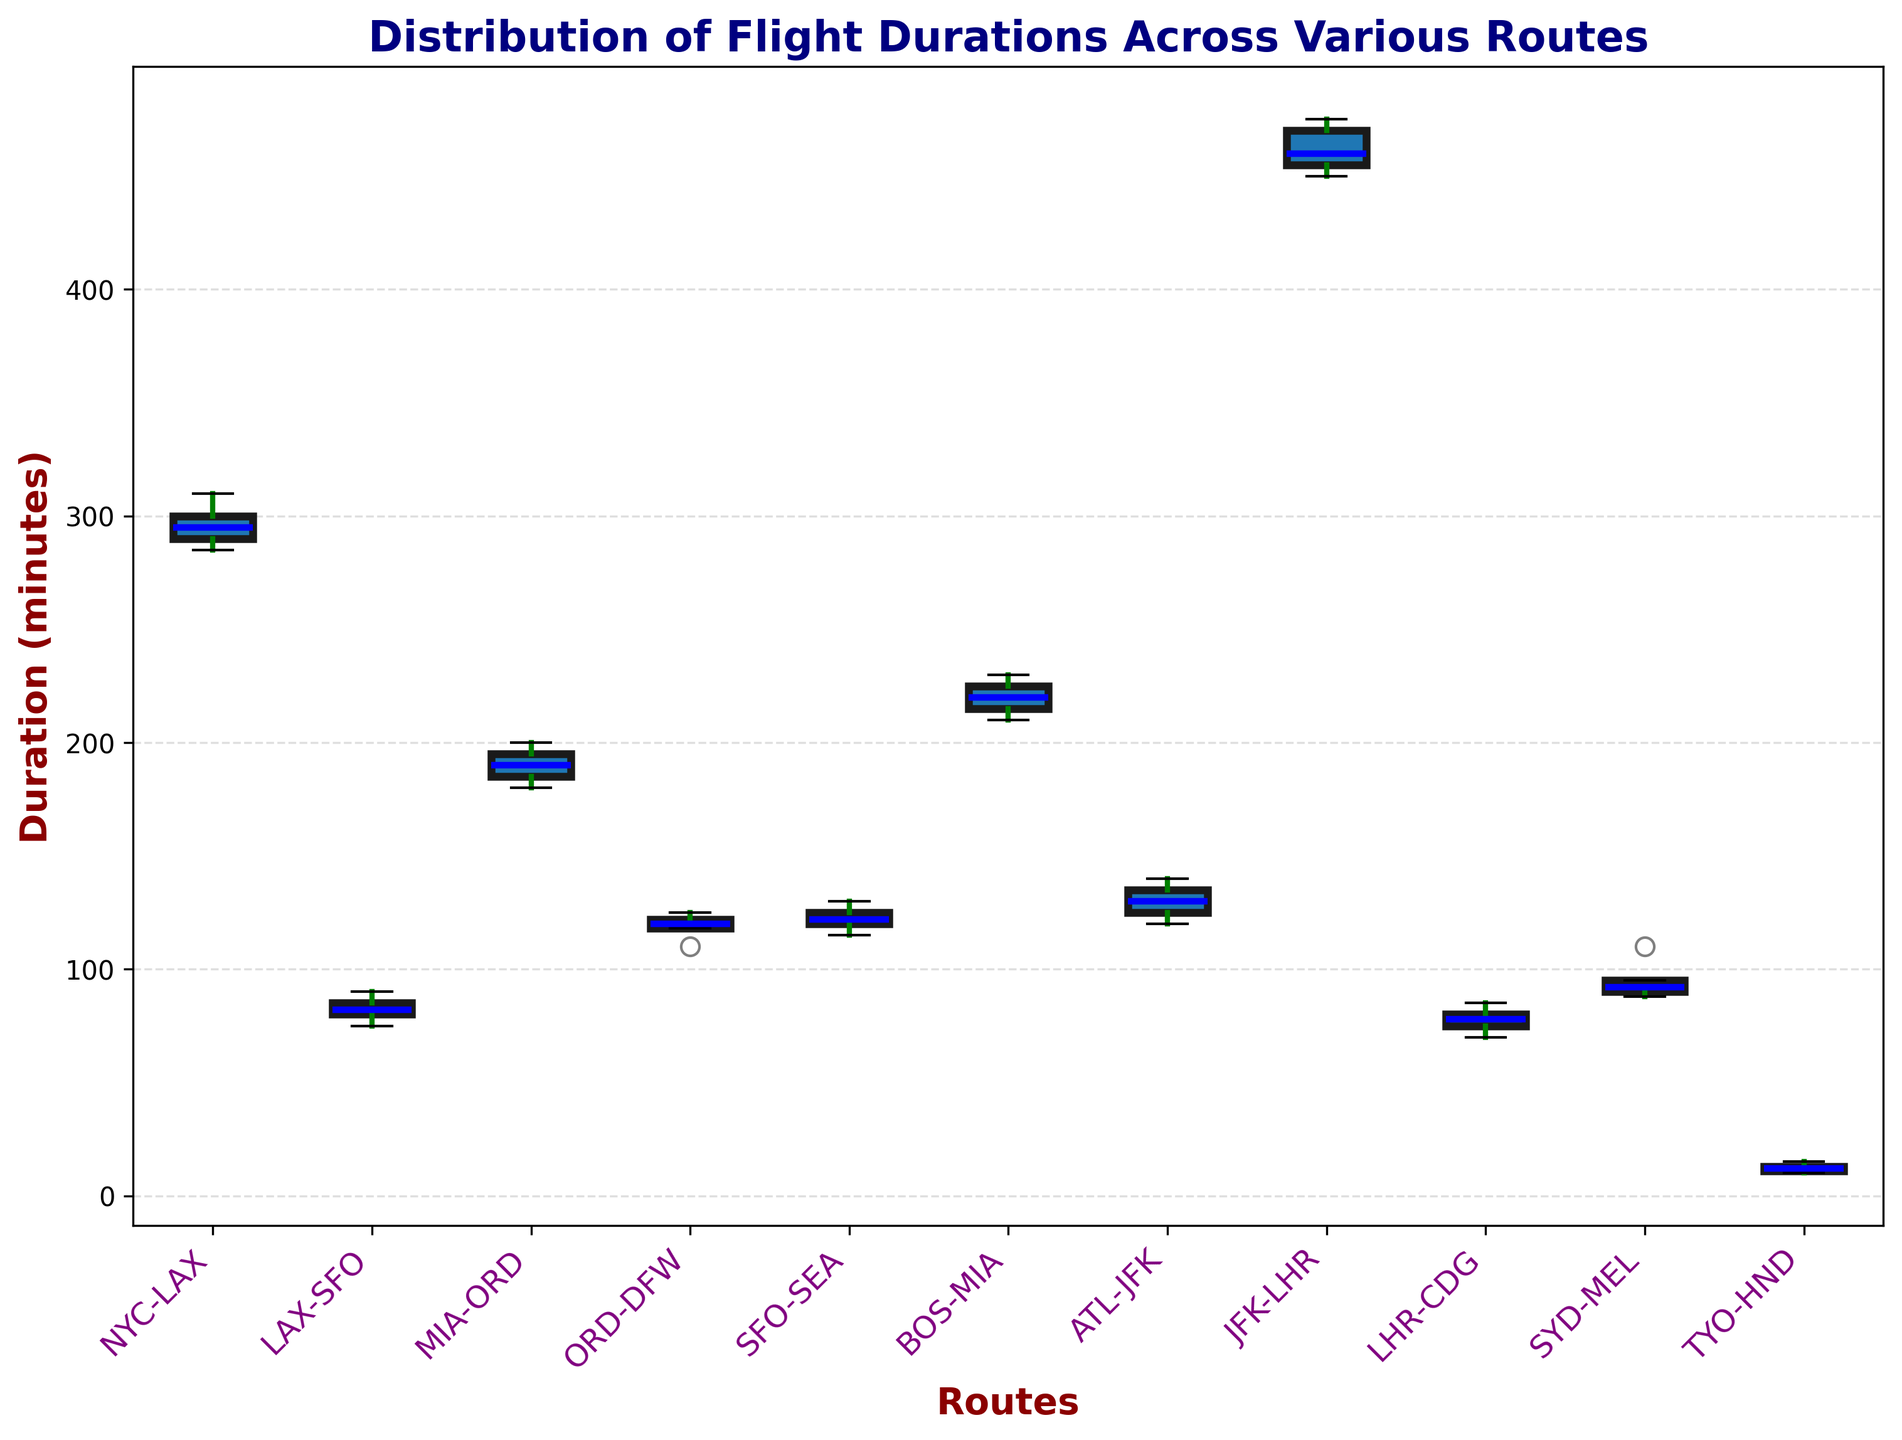Which route has the shortest median duration? To find the answer, locate the middle line (median) within each box plot for all routes. The route with the lowest median line has the shortest median duration.
Answer: TYO-HND Which route has the most spread in flight durations? The spread in flight durations is represented by the length of the box, including the whiskers. Observe each box plot and identify the one with the longest box and whiskers combined.
Answer: JFK-LHR Compare the median flight duration of BOS-MIA and ATL-JFK. Which one is higher? Locate the median (middle line within the box) in both BOS-MIA and ATL-JFK box plots. Compare their positions.
Answer: BOS-MIA What's the interquartile range (IQR) for the LAX-SFO route? The IQR is the range between the first quartile (bottom line of the box) and the third quartile (top line of the box). For LAX-SFO, calculate the difference between these two values.
Answer: 10 minutes Which route has the smallest interquartile range (IQR)? Identify which box plot has the smallest height of the box itself, as this represents the smallest IQR.
Answer: TYO-HND Is there any overlap in flight durations between NYC-LAX and JFK-LHR? Check if the whiskers (lines extending from the boxes) of NYC-LAX and JFK-LHR touch or overlap.
Answer: No Which route has the highest median flight duration? Look for the box plot with the highest median (middle line) among all the routes.
Answer: JFK-LHR Among the routes NYC-LAX, ORD-DFW, and SYD-MEL, which one has the shortest whisker range? Compare the lengths of the whiskers for each of the three mentioned routes. The one with the shortest whiskers has the shortest whisker range.
Answer: ORD-DFW How does the median flight time of MIA-ORD compare to LHR-CDG? Find and compare the medians (middle lines within the boxes) for MIA-ORD and LHR-CDG.
Answer: MIA-ORD is longer What is the approximate median flight duration for the SFO-SEA route? Find the middle line within the box for SFO-SEA and approximate its numerical value using the y-axis.
Answer: 122 minutes 